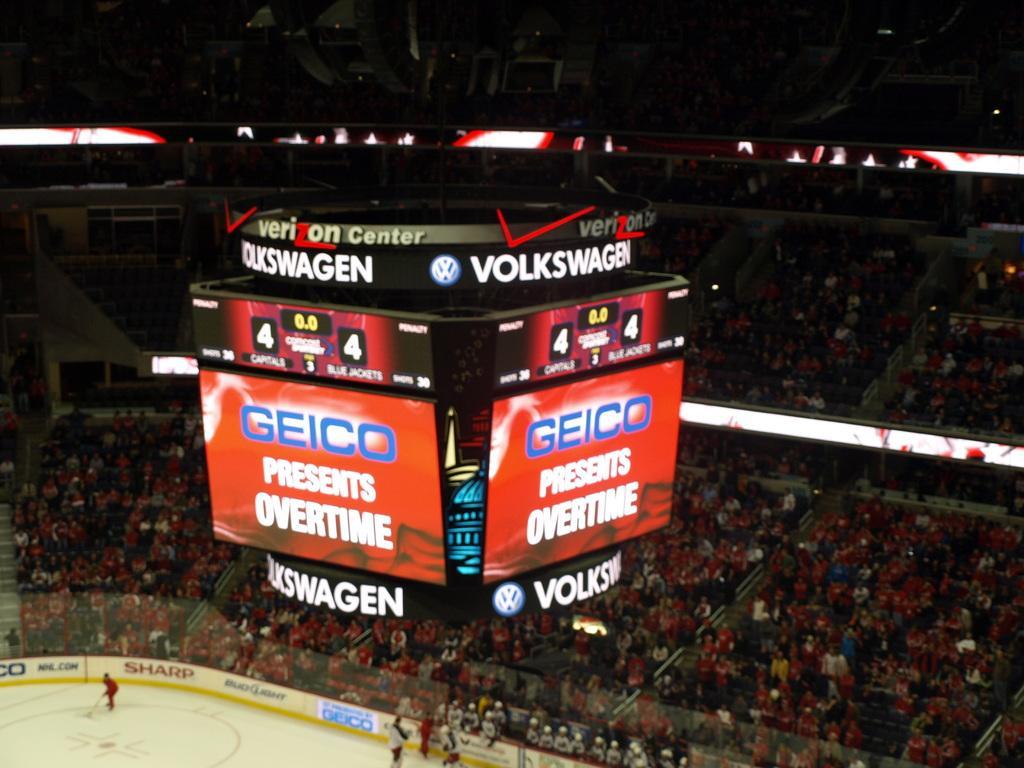In one or two sentences, can you explain what this image depicts? In this image there is a scoreboard, there are few people in the stands and few people on the ground playing a game. 